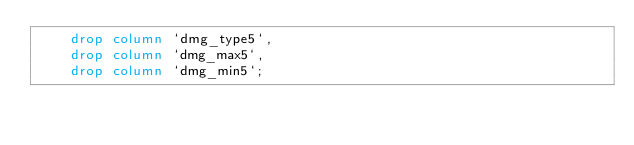Convert code to text. <code><loc_0><loc_0><loc_500><loc_500><_SQL_>    drop column `dmg_type5`,
    drop column `dmg_max5`,
    drop column `dmg_min5`;
</code> 